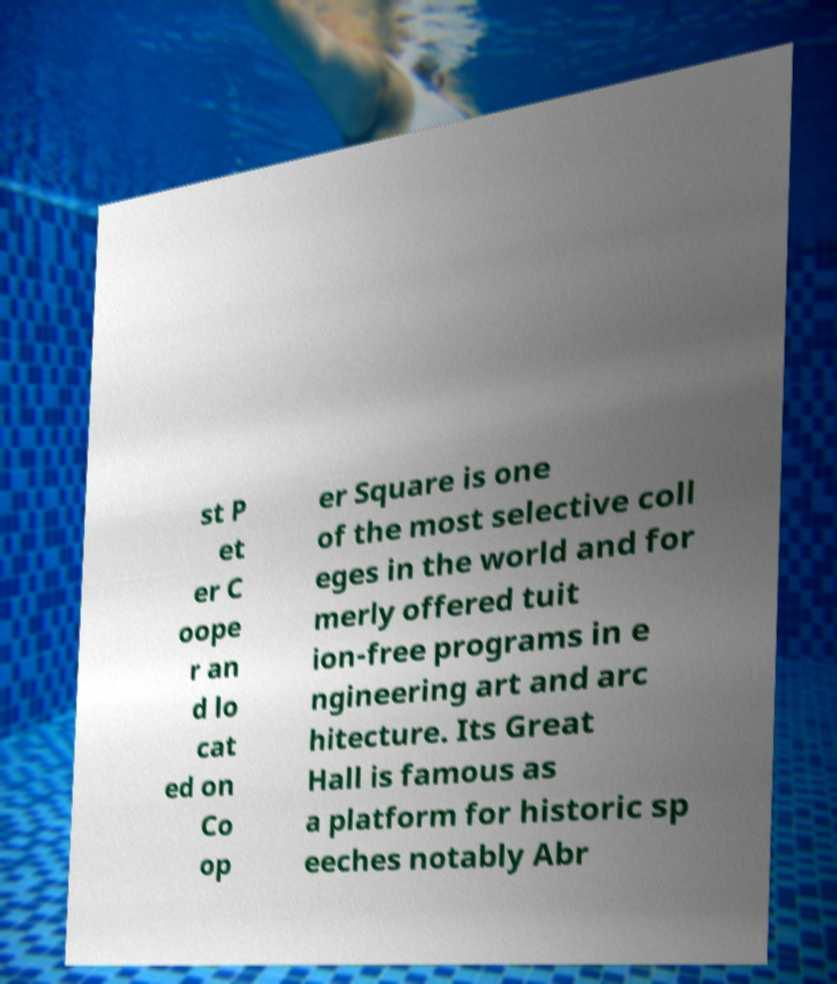Can you read and provide the text displayed in the image?This photo seems to have some interesting text. Can you extract and type it out for me? st P et er C oope r an d lo cat ed on Co op er Square is one of the most selective coll eges in the world and for merly offered tuit ion-free programs in e ngineering art and arc hitecture. Its Great Hall is famous as a platform for historic sp eeches notably Abr 